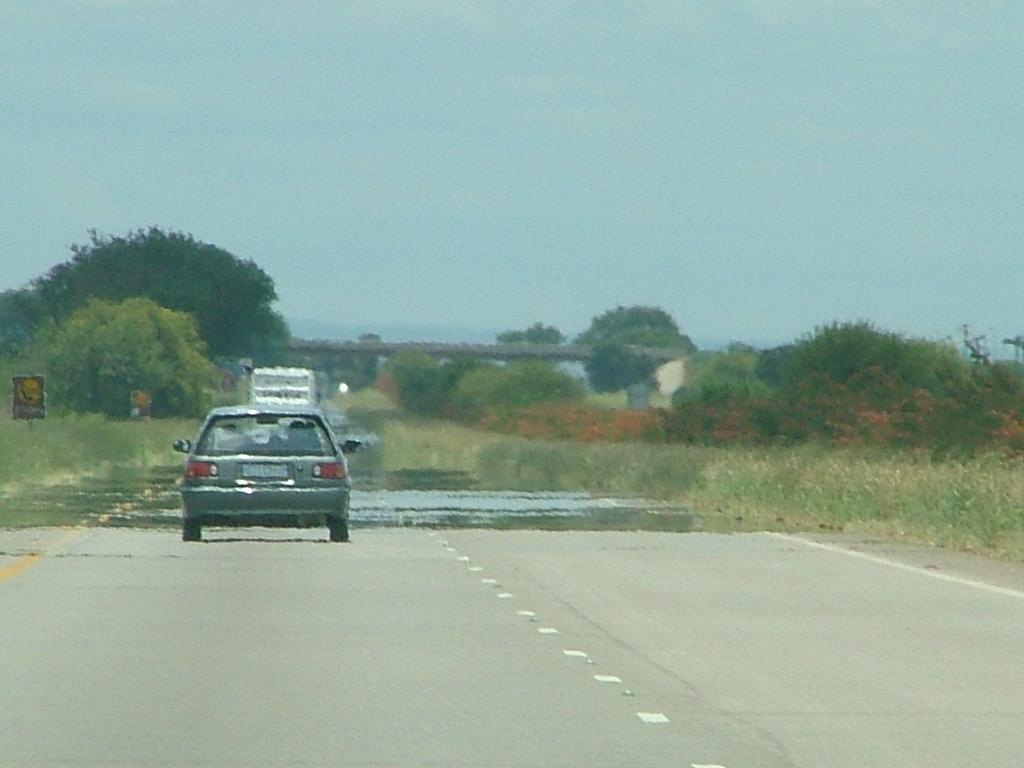Please provide a concise description of this image. In this image we can see some vehicles on the road, some boards with poles, one bridge, some current poles with wires, some trees, bushes, plants and grass on the ground. At the top there is the sky. 